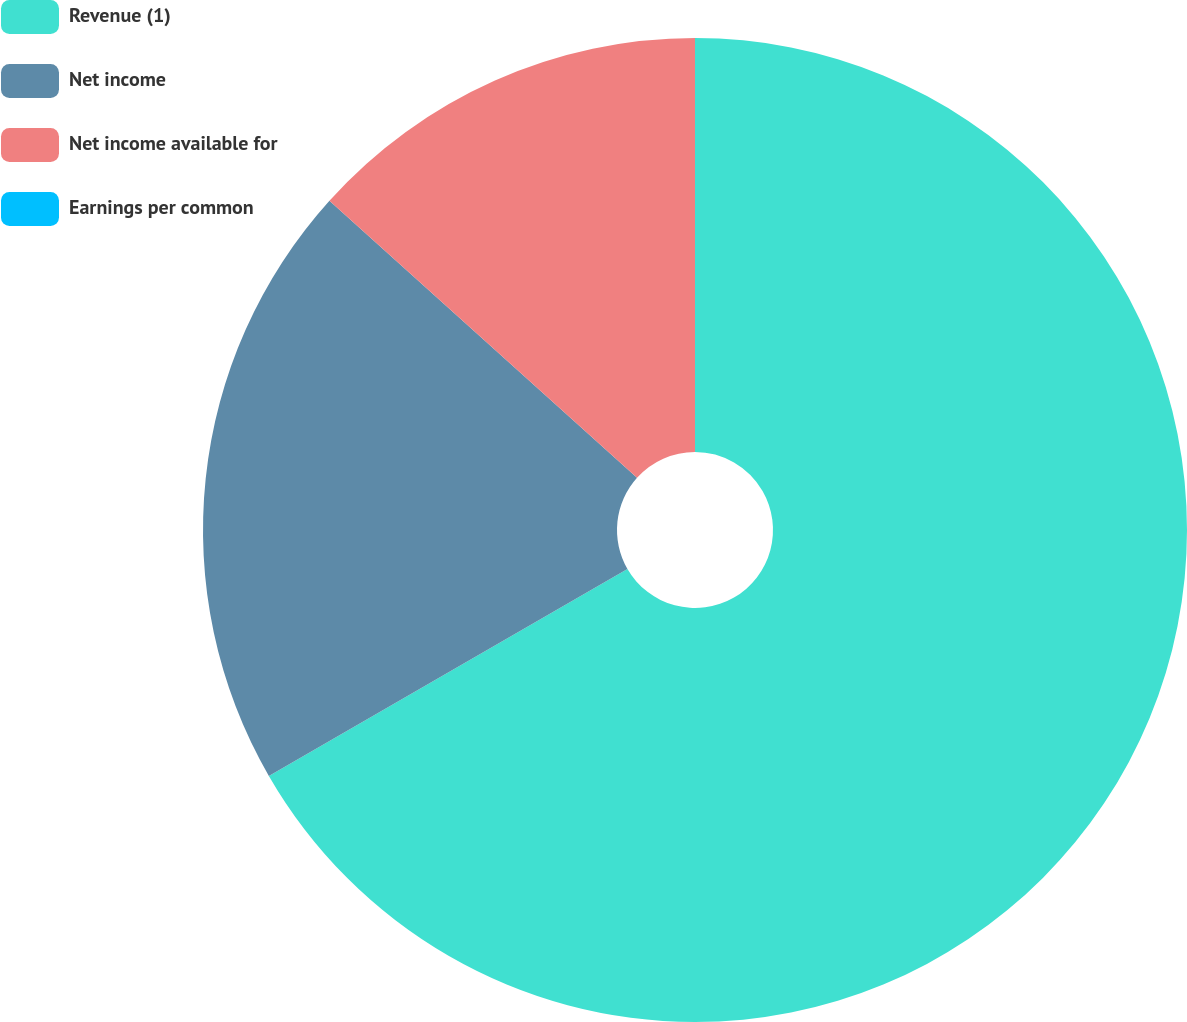Convert chart. <chart><loc_0><loc_0><loc_500><loc_500><pie_chart><fcel>Revenue (1)<fcel>Net income<fcel>Net income available for<fcel>Earnings per common<nl><fcel>66.67%<fcel>20.0%<fcel>13.33%<fcel>0.0%<nl></chart> 